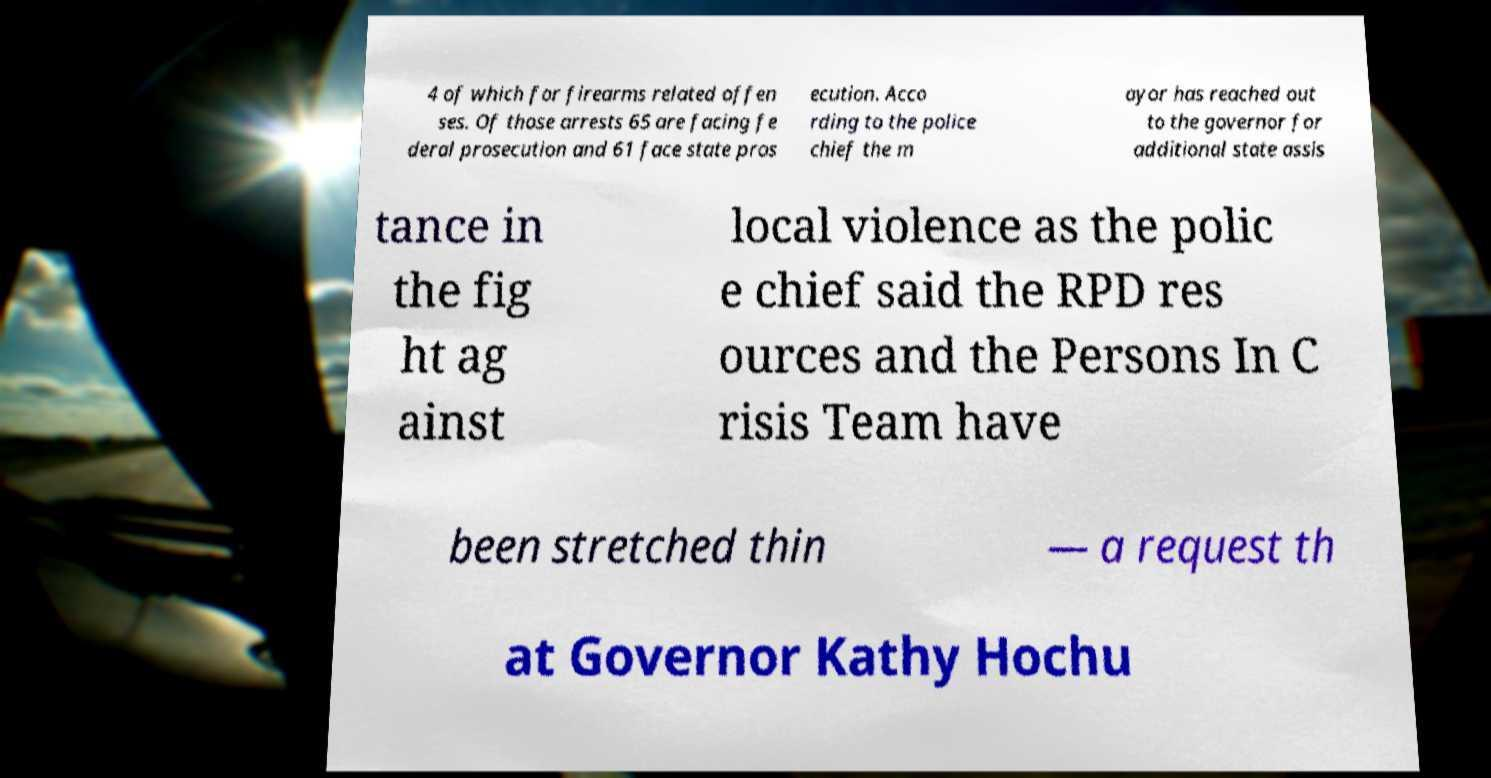Could you extract and type out the text from this image? 4 of which for firearms related offen ses. Of those arrests 65 are facing fe deral prosecution and 61 face state pros ecution. Acco rding to the police chief the m ayor has reached out to the governor for additional state assis tance in the fig ht ag ainst local violence as the polic e chief said the RPD res ources and the Persons In C risis Team have been stretched thin — a request th at Governor Kathy Hochu 